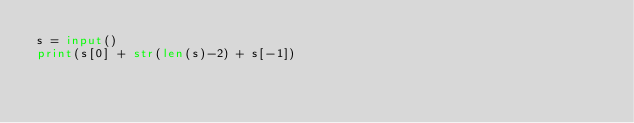<code> <loc_0><loc_0><loc_500><loc_500><_Python_>s = input()
print(s[0] + str(len(s)-2) + s[-1])
</code> 